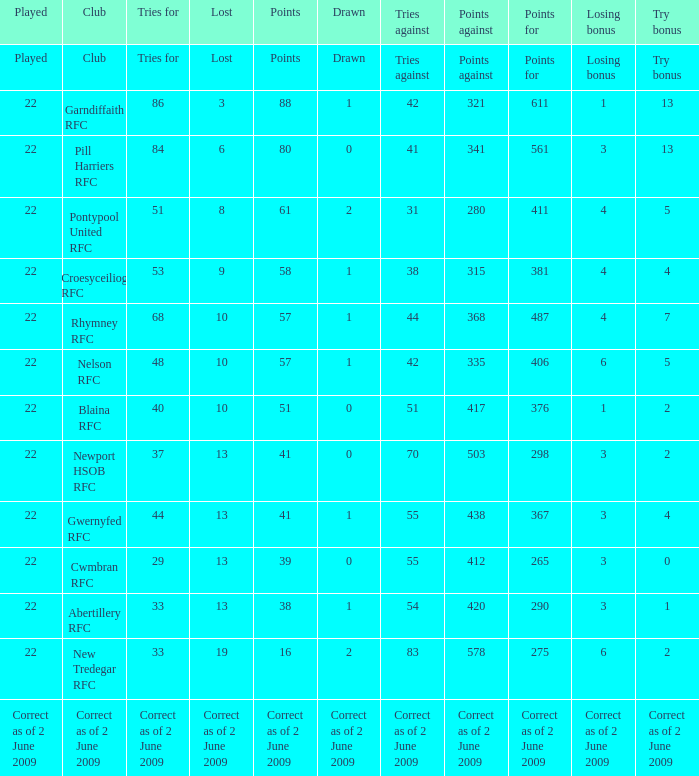How many tries did the club Croesyceiliog rfc have? 53.0. 